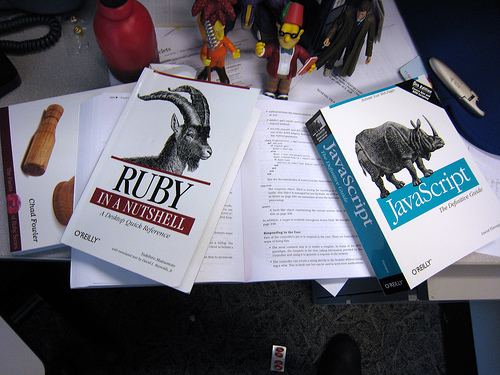<image>
Can you confirm if the ram is to the left of the hippopotamus? Yes. From this viewpoint, the ram is positioned to the left side relative to the hippopotamus. 